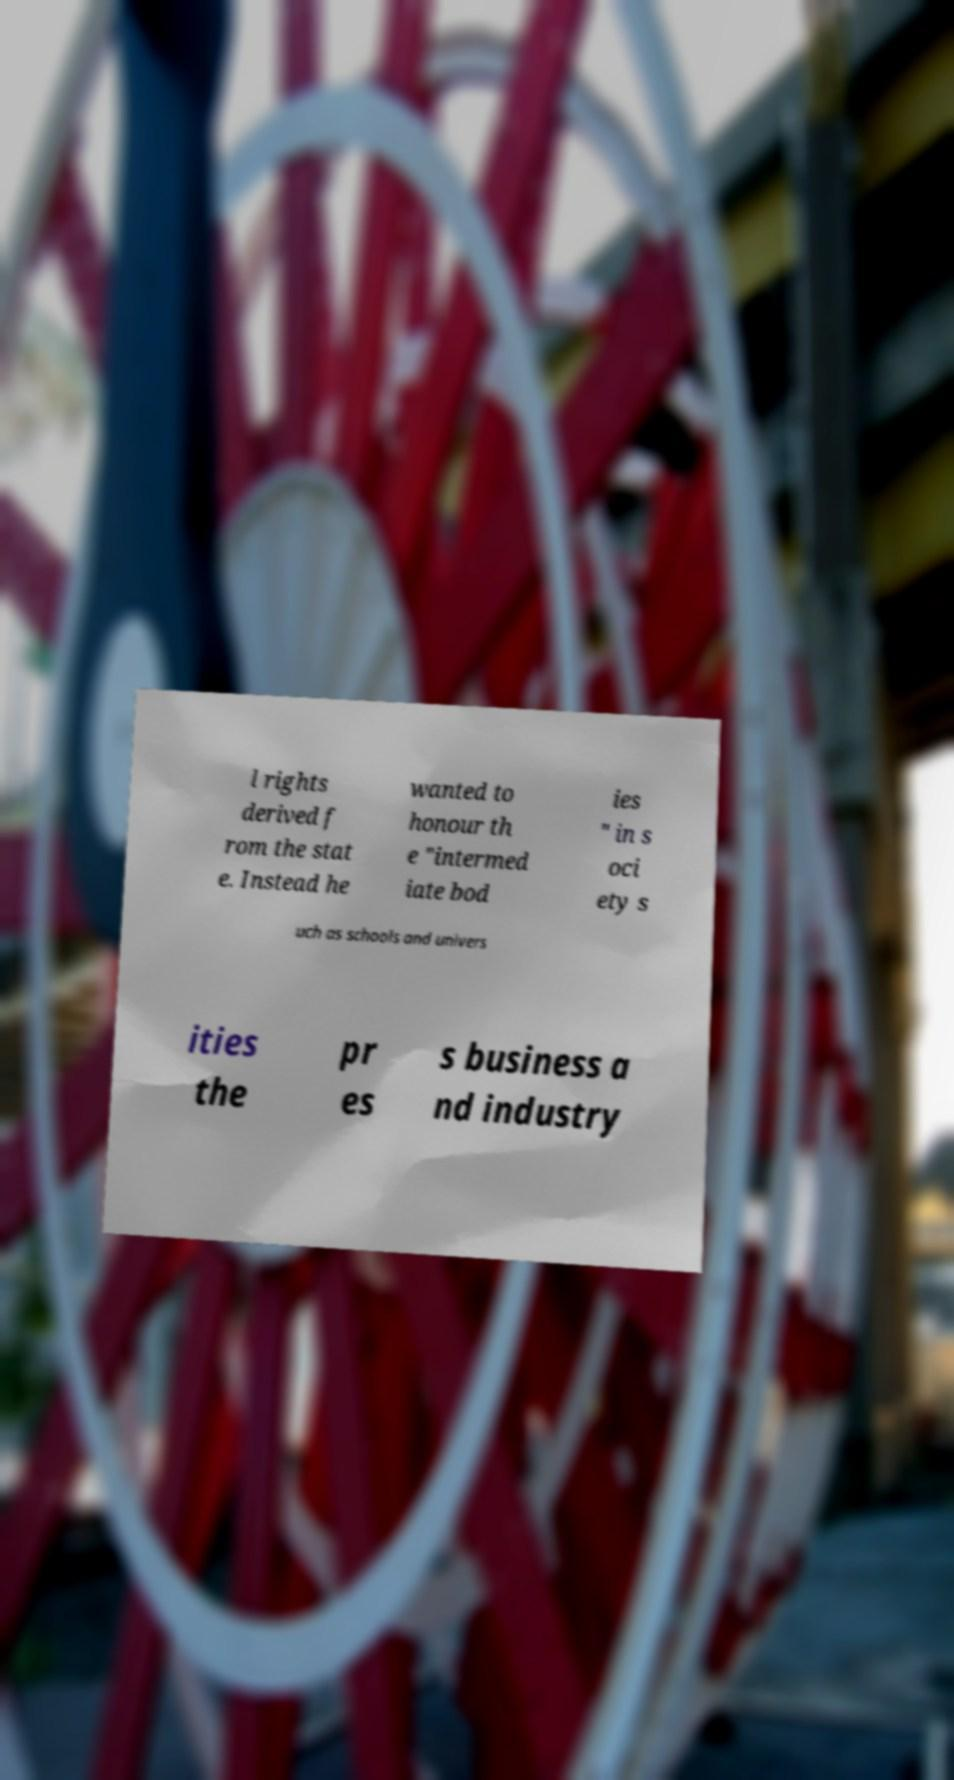Could you extract and type out the text from this image? l rights derived f rom the stat e. Instead he wanted to honour th e "intermed iate bod ies " in s oci ety s uch as schools and univers ities the pr es s business a nd industry 